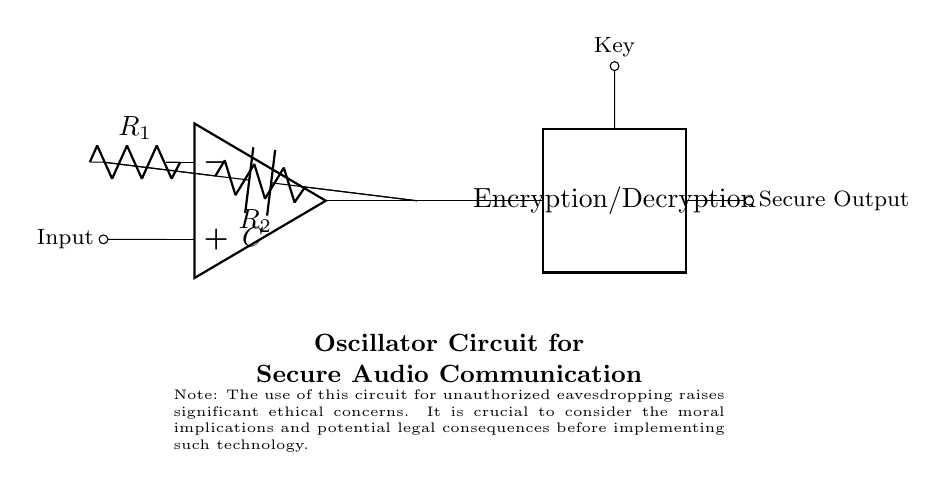What type of circuit is represented? The circuit is an oscillator circuit. This can be inferred from the configuration of components including the operational amplifier and feedback resistors. The operational amplifier setup is characteristic of oscillatory behavior.
Answer: Oscillator What components are used in the circuit? The circuit consists of an operational amplifier, resistors, and a capacitor. These components are visible in the diagram where the op-amp is central, with resistors shown in feedback and output pathways, and a capacitor connected to feedback.
Answer: Operational amplifier, resistors, capacitor What function does the key serve in this circuit? The key is used for encryption and decryption of audio signals. It acts as an input mechanism that allows modification of the output signal to ensure secure communication, which is specifically indicated in the circuit.
Answer: Encryption/Decryption What is the role of resistor R1? Resistor R1 serves as part of the feedback loop in the oscillator circuit. It determines the gain of the op-amp and thus affects the frequency of oscillation, which is crucial for signal modulation in communication.
Answer: Feedback loop How might unauthorized eavesdropping be ethically assessed in this configuration? Unauthorized eavesdropping raises significant ethical concerns due to potential violations of privacy and legality. This underscores the importance of moral implications associated with the use of technology for surveillance purposes, as noted in the ethical consideration in the circuit diagram.
Answer: Ethical concerns What is the output labeled as in the circuit? The output is labeled as "Secure Output." This label indicates that the signal produced by the oscillator circuit is intended for secure communication, highlighting its purpose in maintaining privacy.
Answer: Secure Output How does the capacitor affect the oscillator circuit? The capacitor influences the timing characteristics of the oscillator, determining the charge and discharge cycle that ultimately establishes the frequency of oscillation required for signal modulation. This role is crucial for maintaining the integrity of the audio signals being processed.
Answer: Frequency of oscillation 